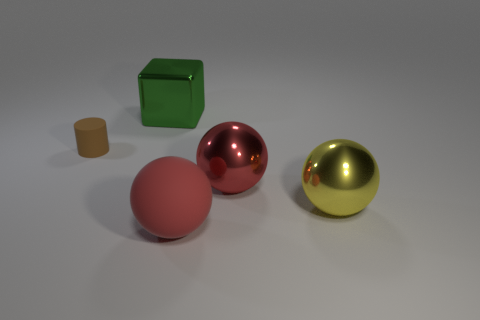Add 3 yellow objects. How many objects exist? 8 Subtract all cylinders. How many objects are left? 4 Add 1 tiny cyan metal cylinders. How many tiny cyan metal cylinders exist? 1 Subtract 0 blue cylinders. How many objects are left? 5 Subtract all large shiny spheres. Subtract all cyan balls. How many objects are left? 3 Add 2 spheres. How many spheres are left? 5 